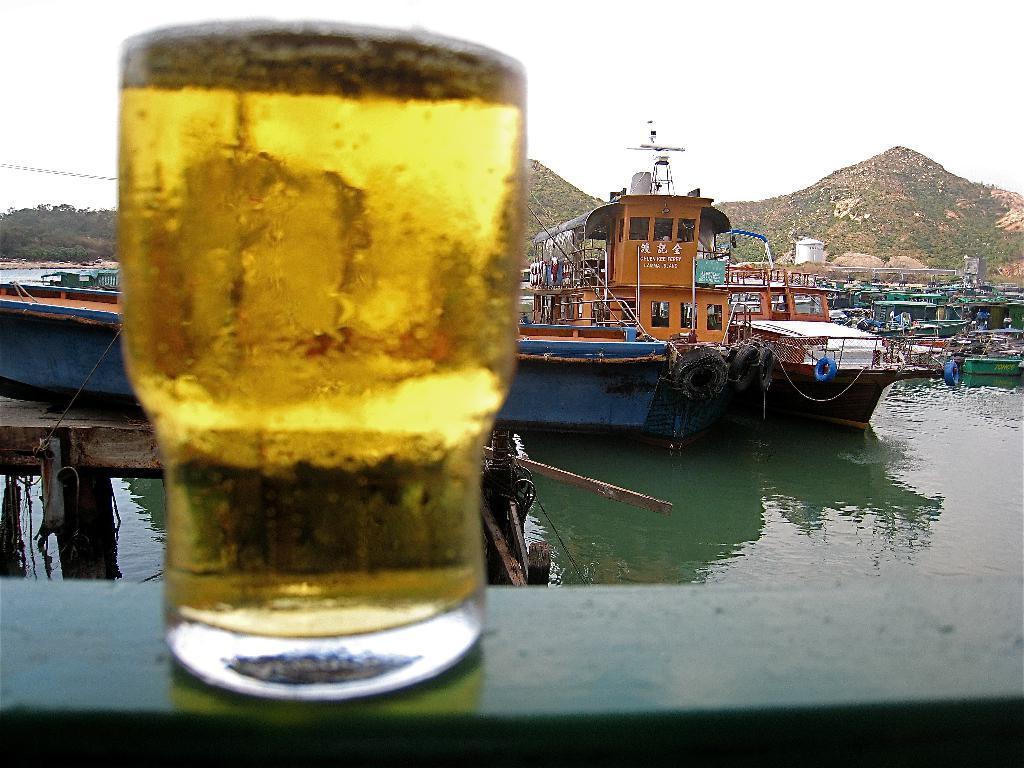Could you give a brief overview of what you see in this image? In this image we can see the glass of wine on a surface, there are some tubes, some ships on the water, also we can see the sky, mountains, and the trees. 